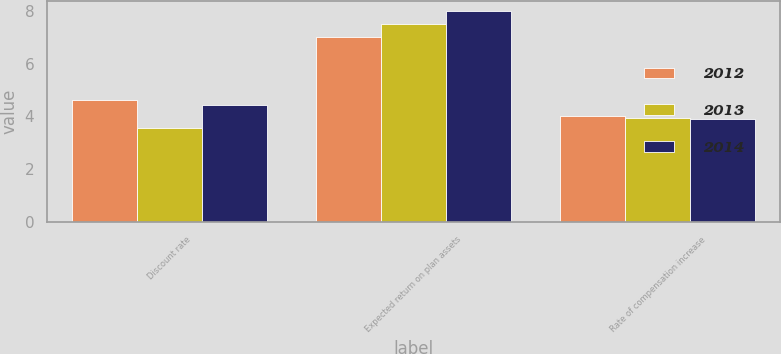Convert chart to OTSL. <chart><loc_0><loc_0><loc_500><loc_500><stacked_bar_chart><ecel><fcel>Discount rate<fcel>Expected return on plan assets<fcel>Rate of compensation increase<nl><fcel>2012<fcel>4.61<fcel>7<fcel>4<nl><fcel>2013<fcel>3.56<fcel>7.5<fcel>3.94<nl><fcel>2014<fcel>4.45<fcel>8<fcel>3.9<nl></chart> 